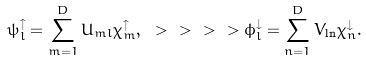Convert formula to latex. <formula><loc_0><loc_0><loc_500><loc_500>\psi _ { l } ^ { \uparrow } = \sum _ { m = 1 } ^ { D } U _ { m l } \chi _ { m } ^ { \uparrow } , \ > \ > \ > \ > \phi _ { l } ^ { \downarrow } = \sum _ { n = 1 } ^ { D } V _ { \ln } \chi _ { n } ^ { \downarrow } .</formula> 